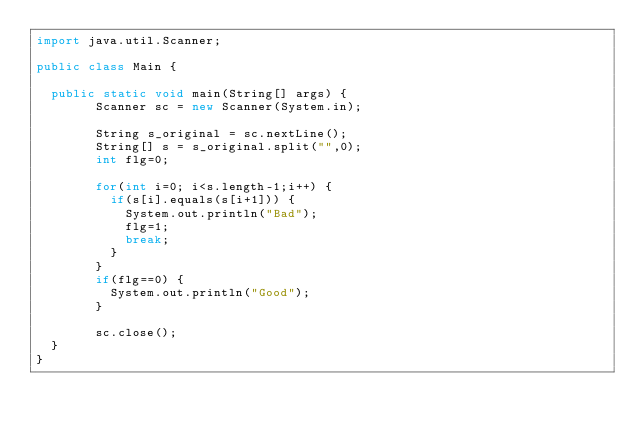Convert code to text. <code><loc_0><loc_0><loc_500><loc_500><_Java_>import java.util.Scanner;

public class Main {

	public static void main(String[] args) {
		    Scanner sc = new Scanner(System.in);

		    String s_original = sc.nextLine();
		    String[] s = s_original.split("",0);
		    int flg=0;

		    for(int i=0; i<s.length-1;i++) {
		    	if(s[i].equals(s[i+1])) {
		    		System.out.println("Bad");
		    		flg=1;
		    		break;
		    	}
		    }
		    if(flg==0) {
		    	System.out.println("Good");
		    }

		    sc.close();
	}
}
</code> 